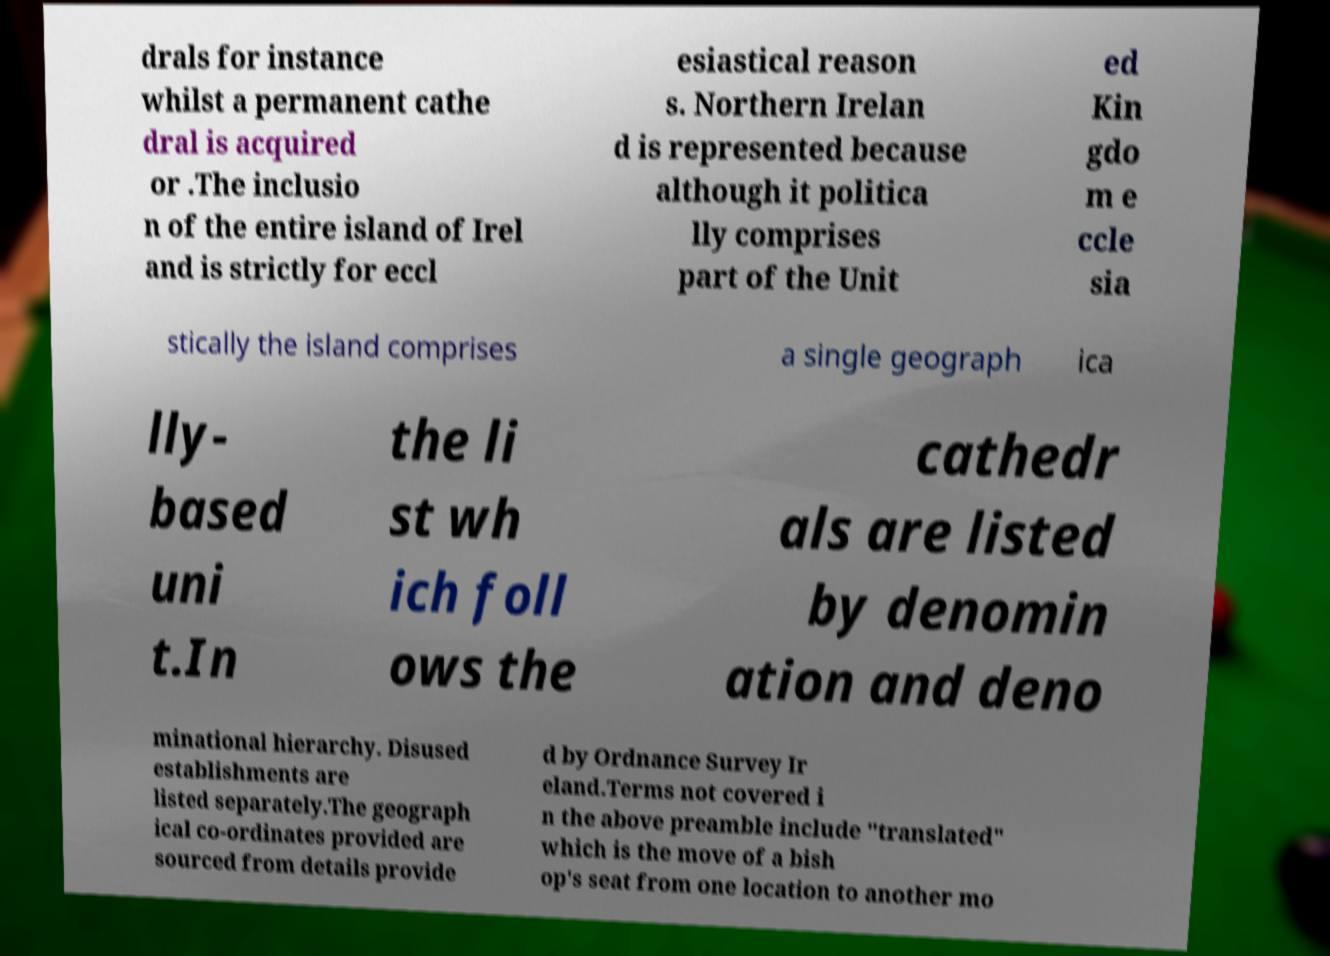For documentation purposes, I need the text within this image transcribed. Could you provide that? drals for instance whilst a permanent cathe dral is acquired or .The inclusio n of the entire island of Irel and is strictly for eccl esiastical reason s. Northern Irelan d is represented because although it politica lly comprises part of the Unit ed Kin gdo m e ccle sia stically the island comprises a single geograph ica lly- based uni t.In the li st wh ich foll ows the cathedr als are listed by denomin ation and deno minational hierarchy. Disused establishments are listed separately.The geograph ical co-ordinates provided are sourced from details provide d by Ordnance Survey Ir eland.Terms not covered i n the above preamble include "translated" which is the move of a bish op's seat from one location to another mo 